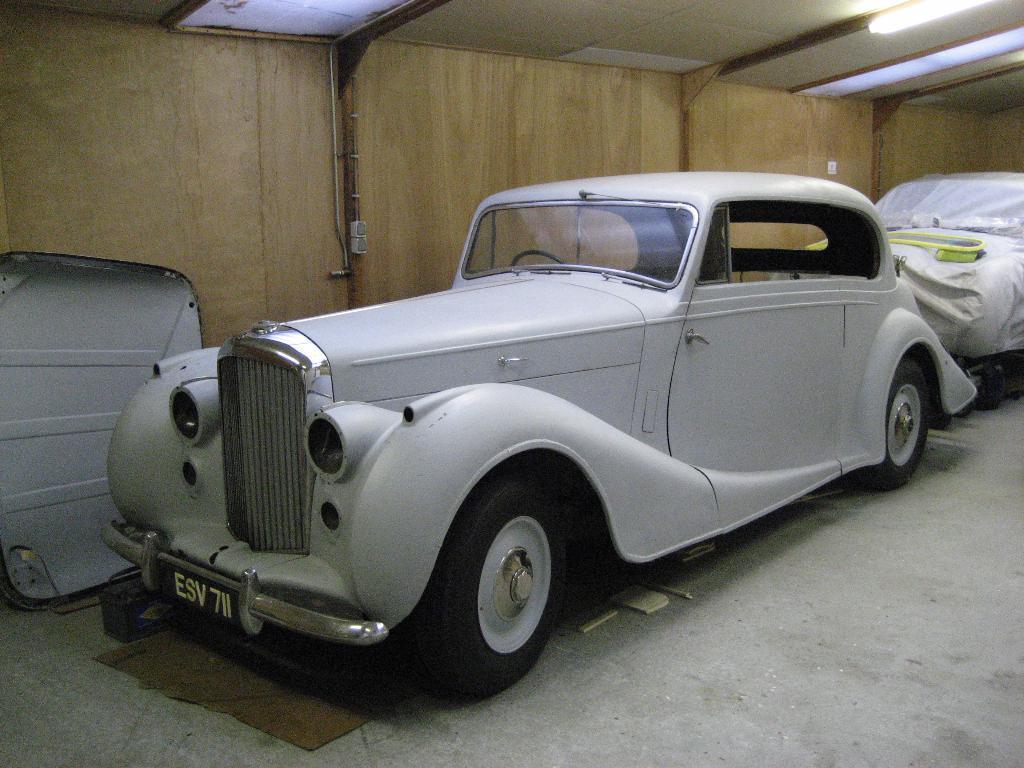Please provide a concise description of this image. In the image there is a car in the foreground, behind the car there is another vehicle covered with a sheet and in the background there is a wall. 